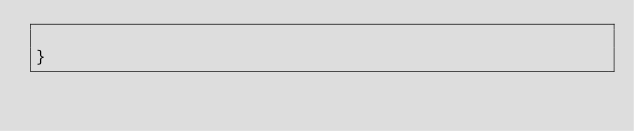Convert code to text. <code><loc_0><loc_0><loc_500><loc_500><_Java_>
}
</code> 